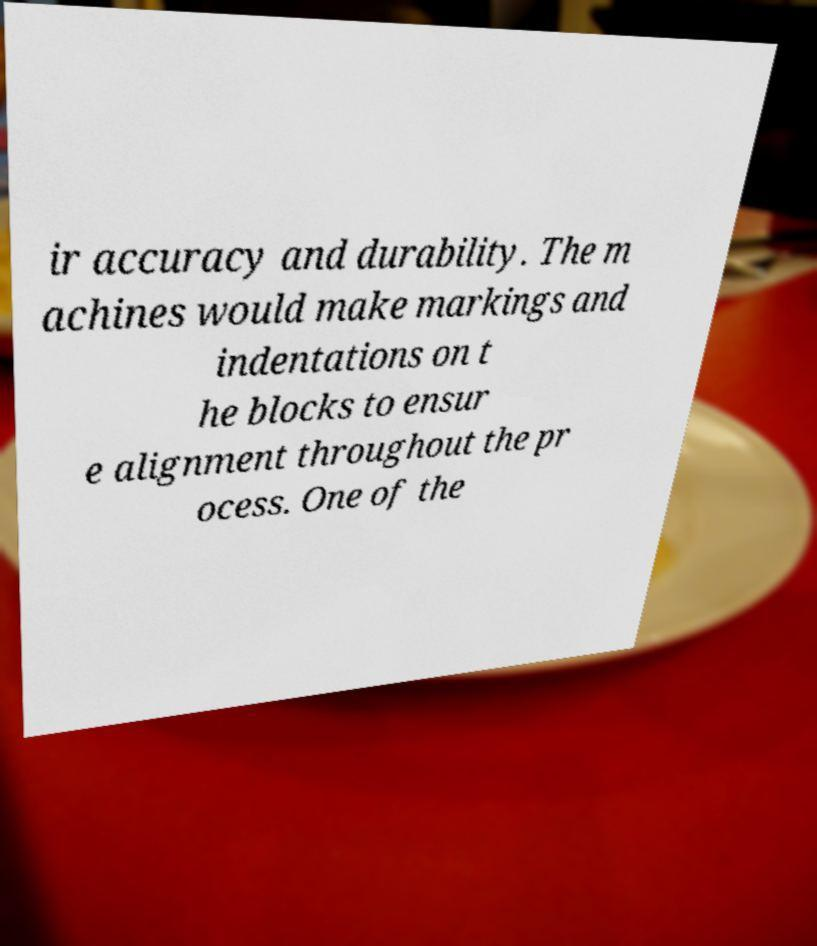What messages or text are displayed in this image? I need them in a readable, typed format. ir accuracy and durability. The m achines would make markings and indentations on t he blocks to ensur e alignment throughout the pr ocess. One of the 